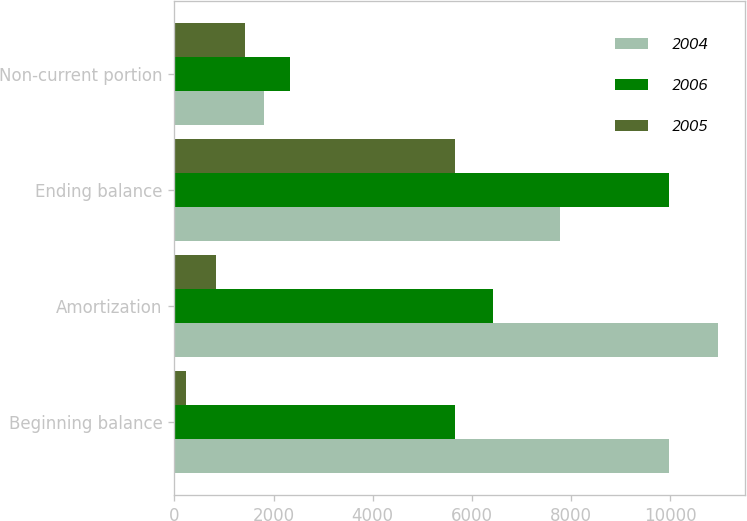Convert chart. <chart><loc_0><loc_0><loc_500><loc_500><stacked_bar_chart><ecel><fcel>Beginning balance<fcel>Amortization<fcel>Ending balance<fcel>Non-current portion<nl><fcel>2004<fcel>9981<fcel>10967<fcel>7766<fcel>1807<nl><fcel>2006<fcel>5665<fcel>6433<fcel>9981<fcel>2330<nl><fcel>2005<fcel>225<fcel>836<fcel>5665<fcel>1425<nl></chart> 